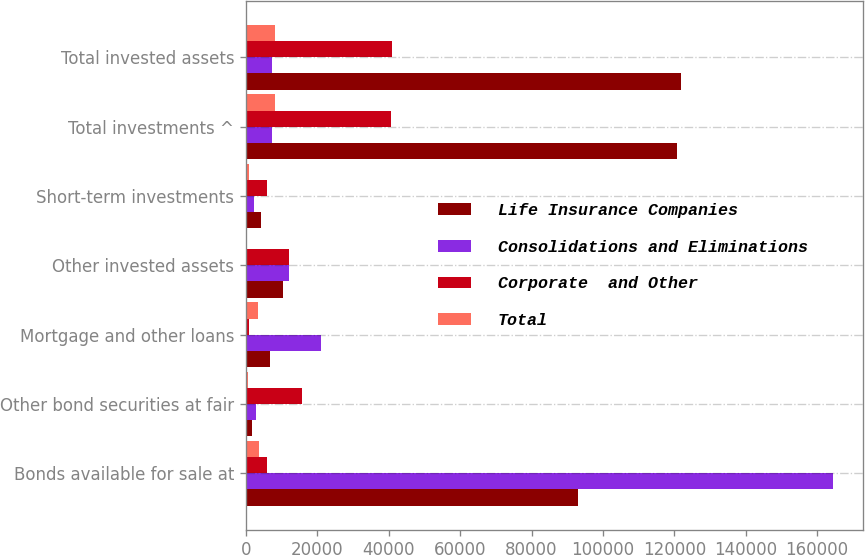Convert chart. <chart><loc_0><loc_0><loc_500><loc_500><stacked_bar_chart><ecel><fcel>Bonds available for sale at<fcel>Other bond securities at fair<fcel>Mortgage and other loans<fcel>Other invested assets<fcel>Short-term investments<fcel>Total investments ^<fcel>Total invested assets<nl><fcel>Life Insurance Companies<fcel>92942<fcel>1733<fcel>6686<fcel>10372<fcel>4154<fcel>120623<fcel>121814<nl><fcel>Consolidations and Eliminations<fcel>164527<fcel>2785<fcel>20874<fcel>11916<fcel>2131<fcel>7345.5<fcel>7345.5<nl><fcel>Corporate  and Other<fcel>5933<fcel>15634<fcel>704<fcel>12109<fcel>5827<fcel>40765<fcel>40881<nl><fcel>Total<fcel>3543<fcel>440<fcel>3274<fcel>121<fcel>869<fcel>8005<fcel>8005<nl></chart> 